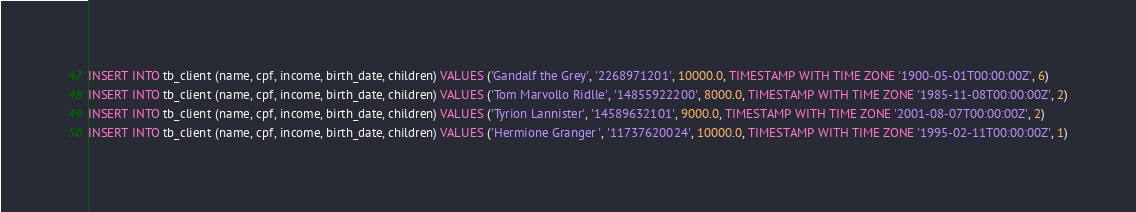Convert code to text. <code><loc_0><loc_0><loc_500><loc_500><_SQL_>INSERT INTO tb_client (name, cpf, income, birth_date, children) VALUES ('Gandalf the Grey', '2268971201', 10000.0, TIMESTAMP WITH TIME ZONE '1900-05-01T00:00:00Z', 6)
INSERT INTO tb_client (name, cpf, income, birth_date, children) VALUES ('Tom Marvollo Ridlle', '14855922200', 8000.0, TIMESTAMP WITH TIME ZONE '1985-11-08T00:00:00Z', 2)
INSERT INTO tb_client (name, cpf, income, birth_date, children) VALUES ('Tyrion Lannister', '14589632101', 9000.0, TIMESTAMP WITH TIME ZONE '2001-08-07T00:00:00Z', 2)
INSERT INTO tb_client (name, cpf, income, birth_date, children) VALUES ('Hermione Granger ', '11737620024', 10000.0, TIMESTAMP WITH TIME ZONE '1995-02-11T00:00:00Z', 1)
</code> 